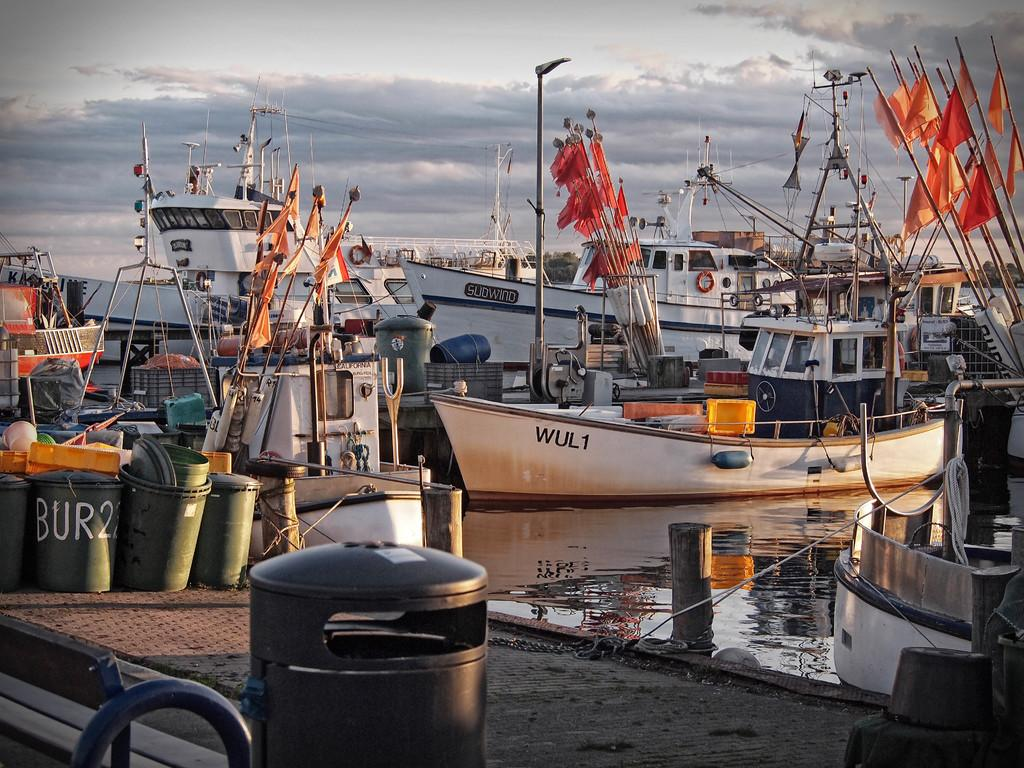Provide a one-sentence caption for the provided image. Boats marked "Sudwind" and ""WUL1" sit in a dock near a barrel painted with the text "Bur22.". 